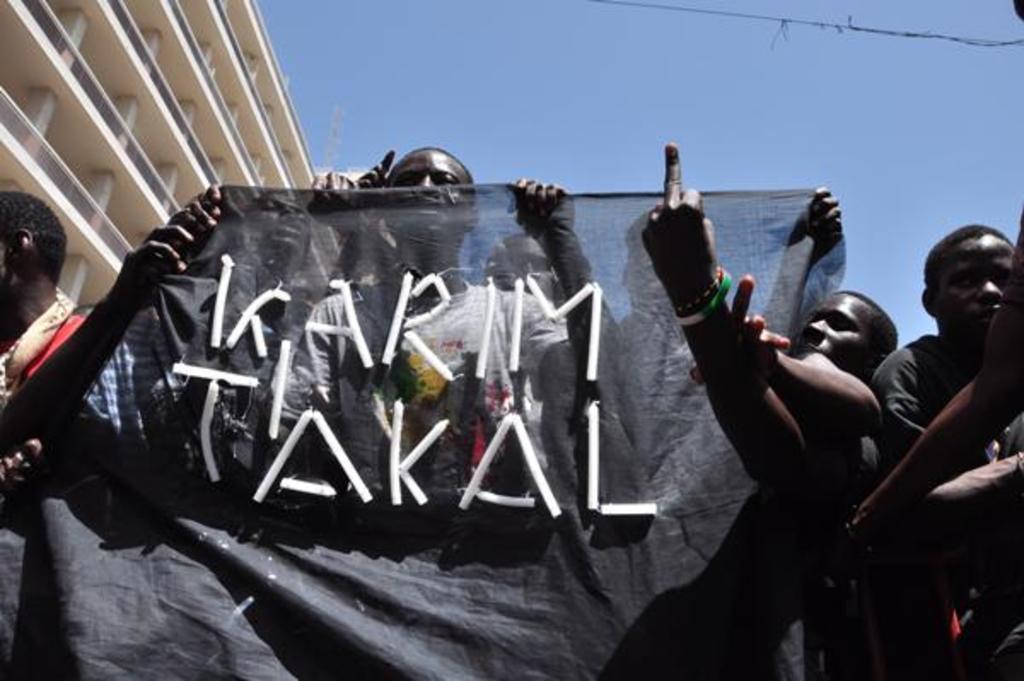Can you describe this image briefly? In this picture we see a building and few people standing and few of them holding a black color cloth with some text on it and we see a blue sky. 